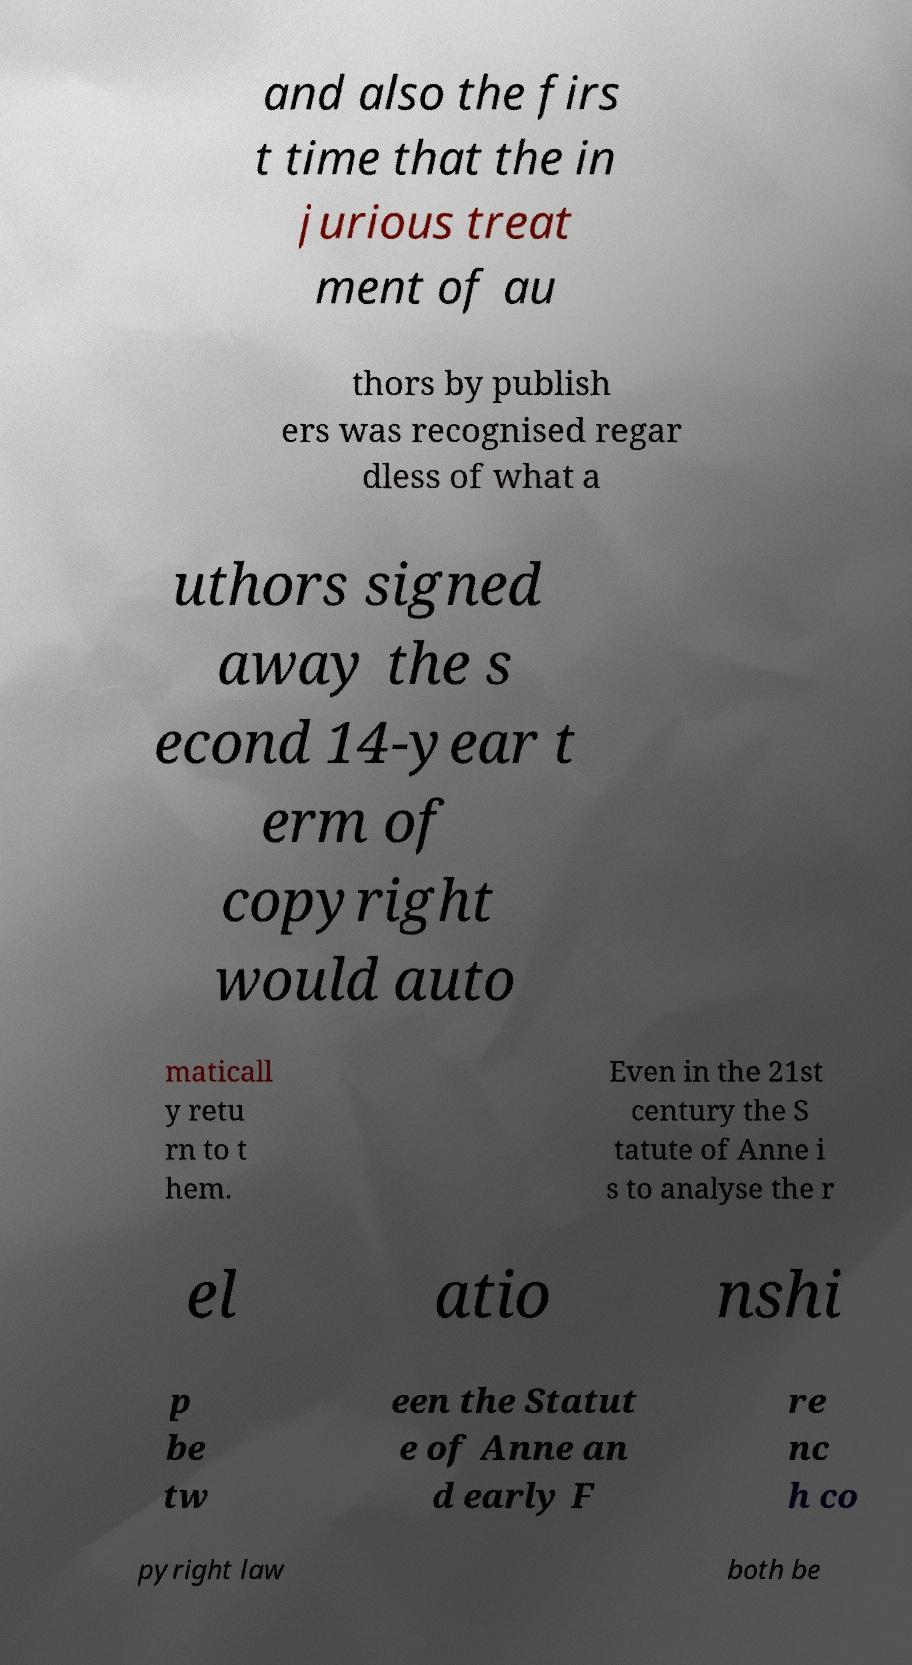Could you assist in decoding the text presented in this image and type it out clearly? and also the firs t time that the in jurious treat ment of au thors by publish ers was recognised regar dless of what a uthors signed away the s econd 14-year t erm of copyright would auto maticall y retu rn to t hem. Even in the 21st century the S tatute of Anne i s to analyse the r el atio nshi p be tw een the Statut e of Anne an d early F re nc h co pyright law both be 